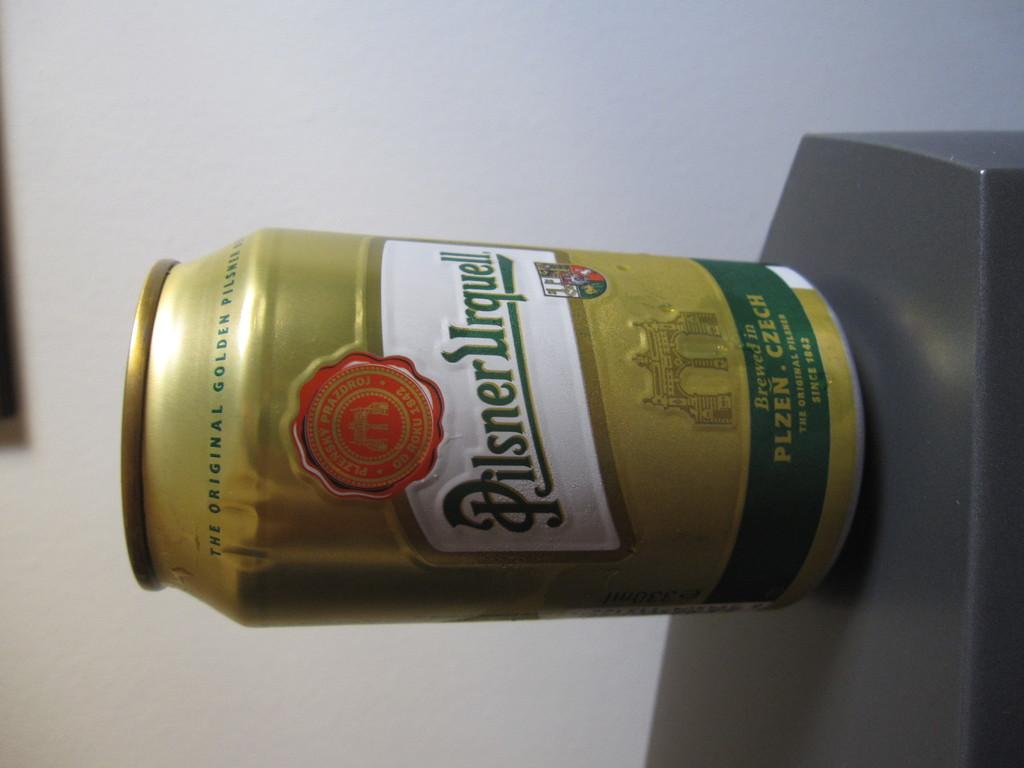<image>
Create a compact narrative representing the image presented. A canned beverage with the label Pilsner Urquell is standing on a black surface. 